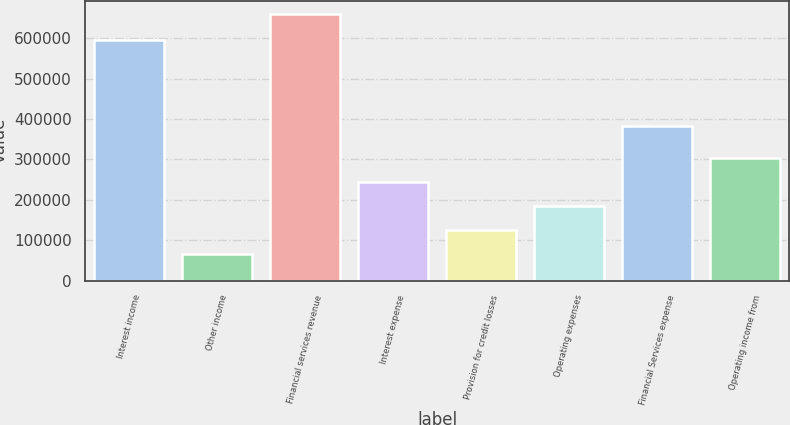Convert chart to OTSL. <chart><loc_0><loc_0><loc_500><loc_500><bar_chart><fcel>Interest income<fcel>Other income<fcel>Financial services revenue<fcel>Interest expense<fcel>Provision for credit losses<fcel>Operating expenses<fcel>Financial Services expense<fcel>Operating income from<nl><fcel>594990<fcel>65837<fcel>660827<fcel>244334<fcel>125336<fcel>184835<fcel>382991<fcel>303833<nl></chart> 